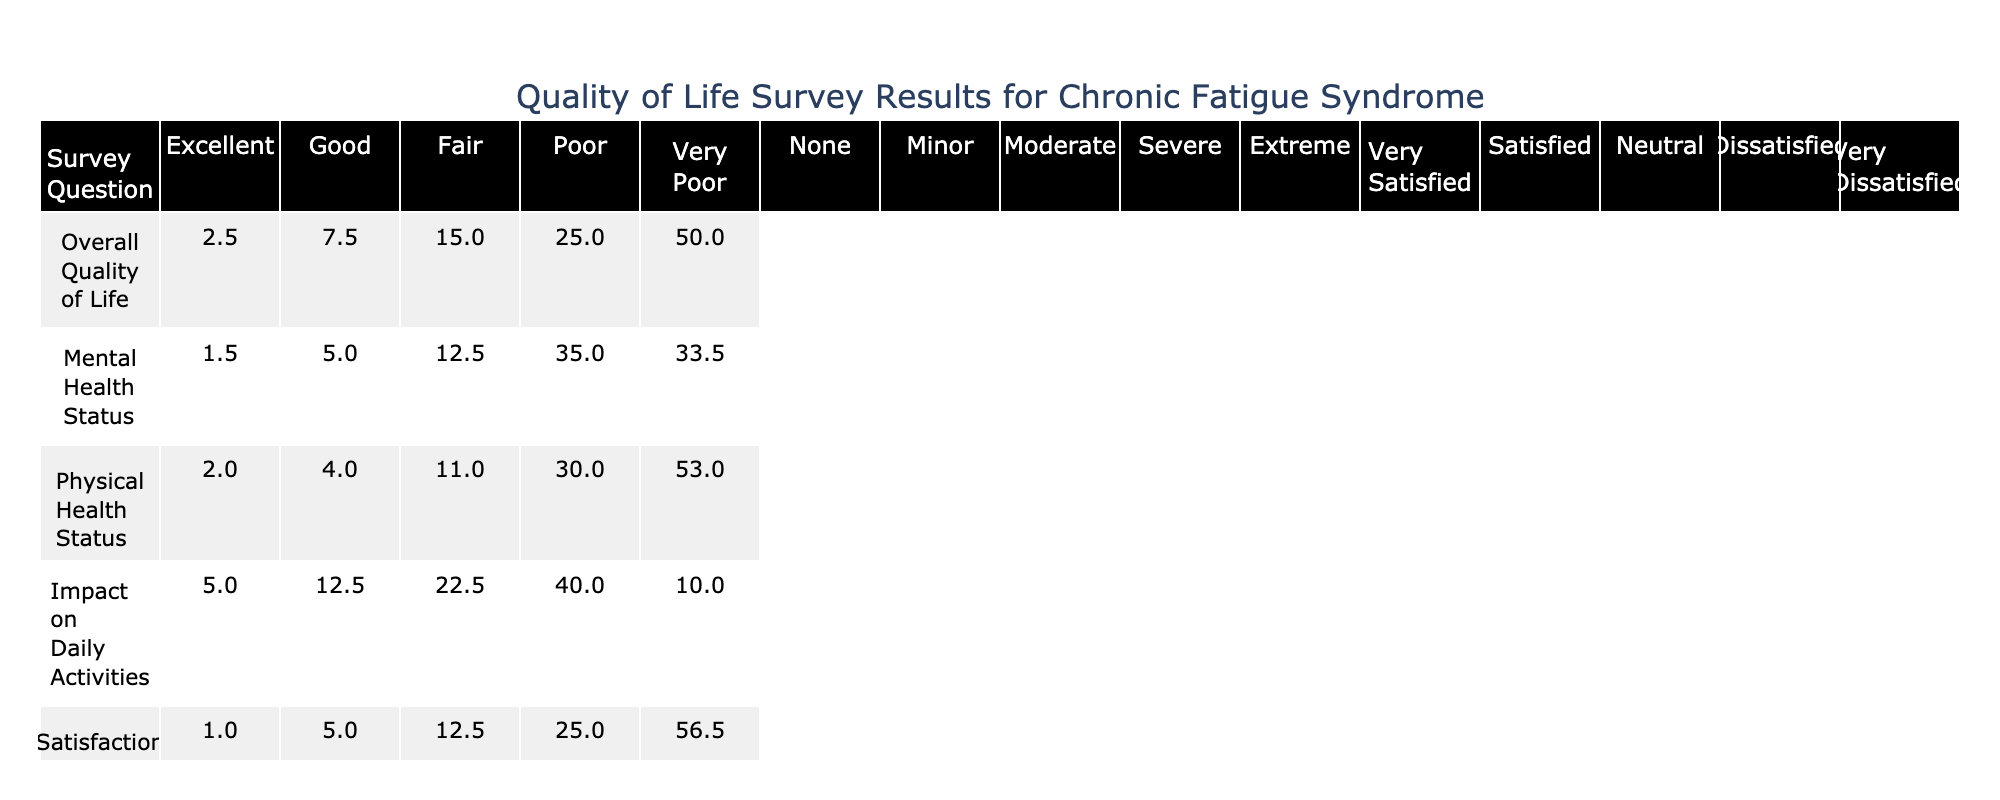What percentage of respondents rated their overall quality of life as "Very Poor"? In the table, the "Overall Quality of Life" row shows that 100 respondents rated their quality of life as "Very Poor," which is 50% of the total respondents.
Answer: 50% How many respondents reported an "Excellent" mental health status? From the "Mental Health Status" row, we see that 3 respondents rated their mental health as "Excellent."
Answer: 3 What is the total percentage of respondents who rated their physical health as either "Poor" or "Very Poor"? The percentages for "Poor" and "Very Poor" physical health status are 30% and 53%, respectively. Adding these gives 30% + 53% = 83%.
Answer: 83% What percentage of respondents are satisfied with their social life? The "Satisfaction with Social Life" responses show that 2% (Very Satisfied) + 10% (Satisfied) = 12%.
Answer: 12% Which survey question had the highest percentage of respondents giving a "Very Poor" rating, and what was that percentage? Checking the "Very Poor" category for each question reveals that "Satisfaction with Social Life" has 56.5%, the highest among all categories.
Answer: "Satisfaction with Social Life", 56.5% What is the difference in the percentage of respondents rating their physical health as "Fair" versus those rating it as "Good"? The percentage for "Fair" physical health status is 11%, while for "Good" it is 4%. The difference is 11% - 4% = 7%.
Answer: 7% What is the most common impact on daily activities reported by respondents? The table shows that 40% of respondents reported a "Severe" impact on daily activities, which is the highest among all response categories for that question.
Answer: "Severe" Are there more respondents who rated their overall quality of life as "Fair" than those who rated their mental health as "Good"? "Fair" overall quality of life has 30 respondents, while only 10 rated their mental health as "Good." Since 30 is greater than 10, the answer is yes.
Answer: Yes Calculate the average percentage of respondents who reported a "Moderate" or "Severe" impact on daily activities. The percentages for "Moderate" and "Severe" impacts are 22.5% and 40%. Adding these gives 22.5 + 40 = 62.5%. To find the average, divide by 2, yielding 62.5% / 2 = 31.25%.
Answer: 31.25% What fraction of respondents reported dissatisfaction with their social life (Dissatisfied + Very Dissatisfied)? The "Dissatisfied" category has 25%, and "Very Dissatisfied" has 56.5%. The total dissatisfaction is 25% + 56.5% = 81.5%. This can be represented as 81.5 out of 100 respondents.
Answer: 81.5% 